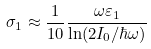Convert formula to latex. <formula><loc_0><loc_0><loc_500><loc_500>\sigma _ { 1 } \approx \frac { 1 } { 1 0 } \frac { \omega \varepsilon _ { 1 } } { \ln ( 2 I _ { 0 } / \hbar { \omega } ) }</formula> 